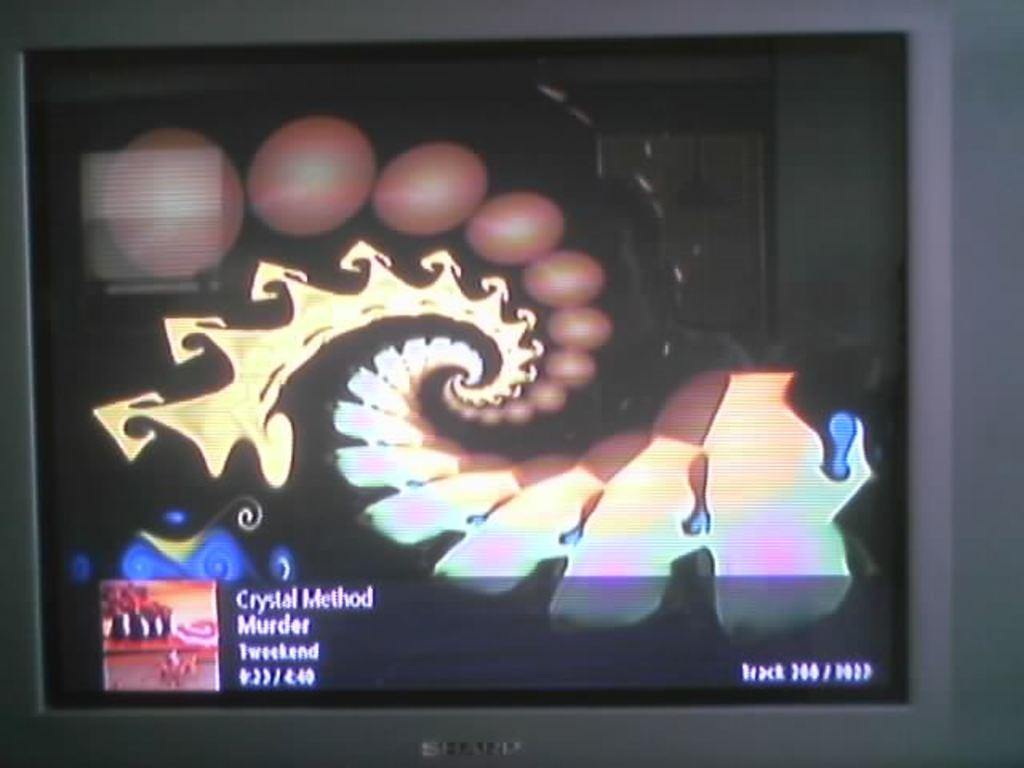<image>
Share a concise interpretation of the image provided. a tv monitor about to show the movie crystal murder film 